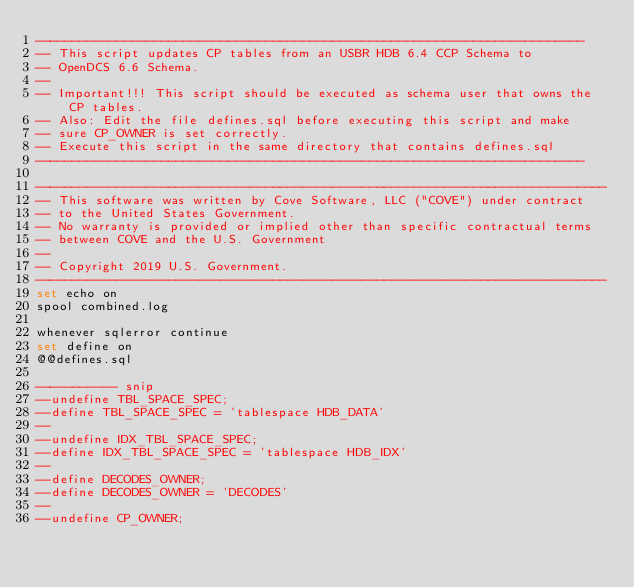Convert code to text. <code><loc_0><loc_0><loc_500><loc_500><_SQL_>--------------------------------------------------------------------------
-- This script updates CP tables from an USBR HDB 6.4 CCP Schema to 
-- OpenDCS 6.6 Schema.
--
-- Important!!! This script should be executed as schema user that owns the CP tables.
-- Also: Edit the file defines.sql before executing this script and make 
-- sure CP_OWNER is set correctly.
-- Execute this script in the same directory that contains defines.sql
--------------------------------------------------------------------------

-----------------------------------------------------------------------------
-- This software was written by Cove Software, LLC ("COVE") under contract 
-- to the United States Government. 
-- No warranty is provided or implied other than specific contractual terms
-- between COVE and the U.S. Government
-- 
-- Copyright 2019 U.S. Government.
-----------------------------------------------------------------------------
set echo on
spool combined.log
    
whenever sqlerror continue
set define on
@@defines.sql

----------- snip
--undefine TBL_SPACE_SPEC;
--define TBL_SPACE_SPEC = 'tablespace HDB_DATA'
--
--undefine IDX_TBL_SPACE_SPEC;
--define IDX_TBL_SPACE_SPEC = 'tablespace HDB_IDX'
--
--define DECODES_OWNER;
--define DECODES_OWNER = 'DECODES'
--
--undefine CP_OWNER;</code> 